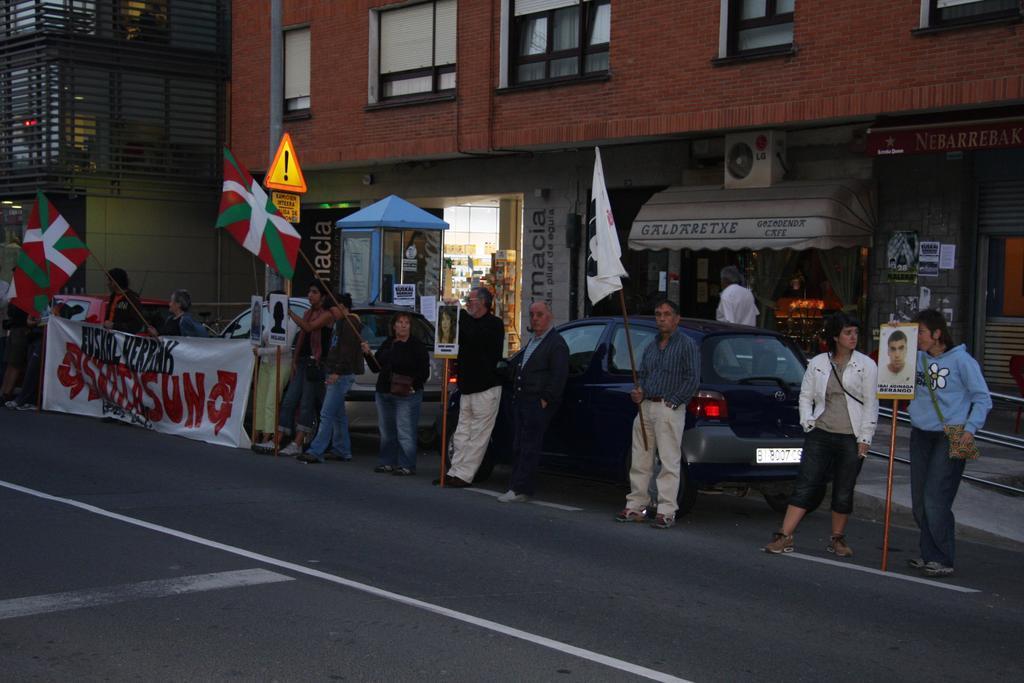In one or two sentences, can you explain what this image depicts? This picture is clicked outside the city. In this picture, we see the people are standing and they are holding the flags and the boards in their hands. These flags are in red, green and white color. On the left side, we see the people are holding a white banner with some text written on it. I think they are protesting against something. Behind them, we see the cars and a board in orange and yellow color. In the background, we see the buildings and the stalls. On the right side, we see a board in red color with some text written on it. 